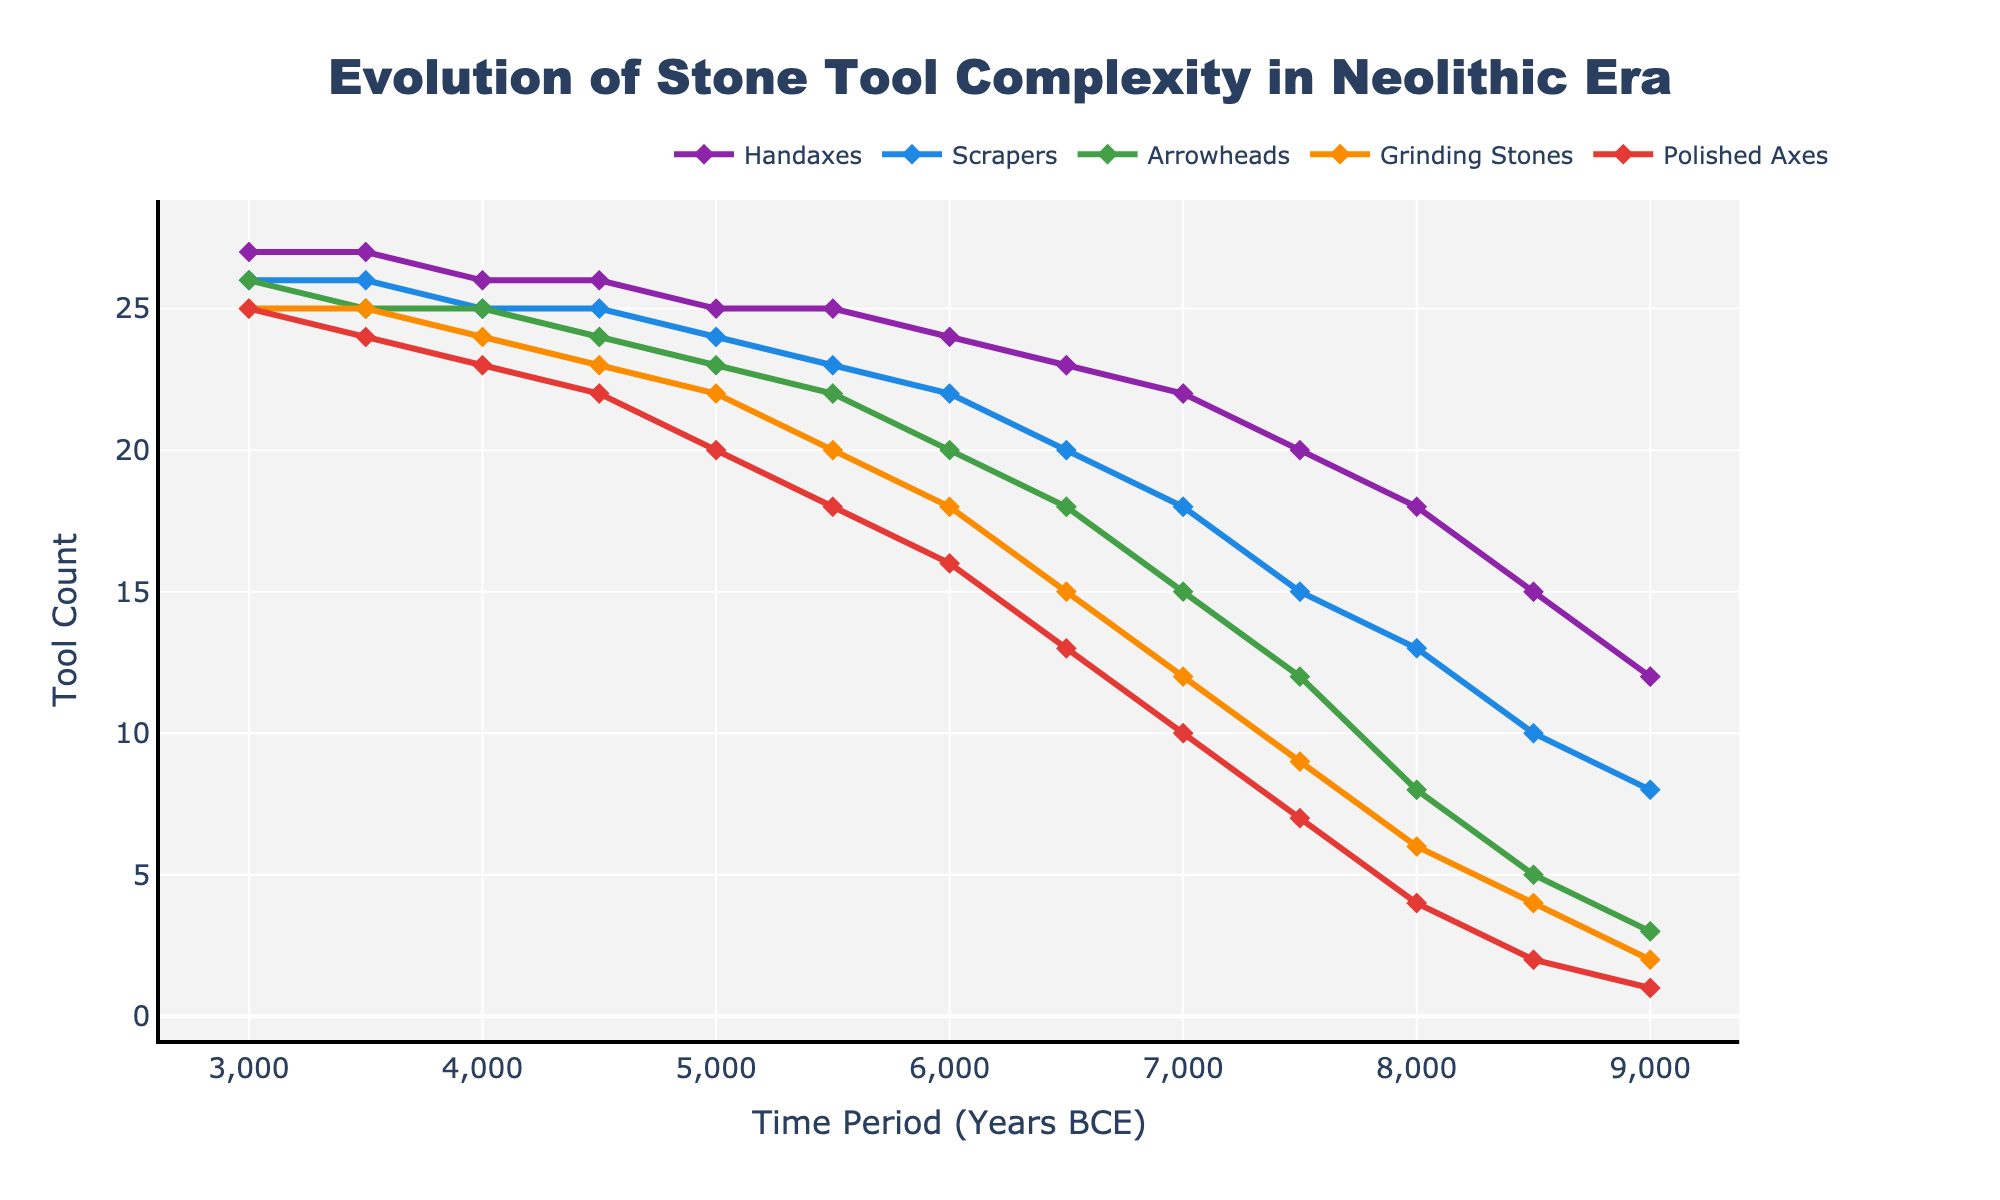What time period marks the first appearance of all five tool types in the chart? Identify the point where all lines start, indicating the presence of each tool type in the record. The first time period where all tools are present is 8500 BCE.
Answer: 8500 BCE Which tool type shows the highest increase in count from 9000 BCE to 8000 BCE? Compare the increases of each tool type between these periods by subtracting counts. Handaxes: 18-12=6, Scrapers: 13-8=5, Arrowheads: 8-3=5, Grinding Stones: 6-2=4, Polished Axes: 4-1=3. Handaxes show the highest increase of 6.
Answer: Handaxes At what time period do Polished Axes first reach the same count as Arrowheads? Locate the point in time where the values for both tools are identical. In 6000 BCE, both Polished Axes and Arrowheads reach a count of 16.
Answer: 6000 BCE How many more Grinding Stones were there compared to Arrowheads in 5500 BCE? Subtract the count of Arrowheads from the count of Grinding Stones in 5500 BCE. Grinding Stones: 20, Arrowheads: 22. The difference is 20-22=-2.
Answer: -2 (2 fewer Grinding Stones) Which time period shows the smallest increase in the number of handaxes compared to the previous period? Calculate the differences between consecutive periods for Handaxes, then identify the smallest increase. Between 8500-9000: 3, 8000-8500: 3, 7500-8000: 2, 7000-7500: 2, 6500-7000: 1, 6000-6500: 1, 5500-6000: 1, 5000-5500: 0, 4500-5000: 1, 4000-4500: 0, 3500-4000: 1, 3000-3500: 0. The smallest increase is 0, occurring from 5500 BCE onward.
Answer: 3000 BCE, 4000 BCE, 5000 BCE, 5500 BCE What is the median count of Scrapers over the entire time period? Arrange the scraper counts in ascending order and find the middle value(s). Sorted counts: 8, 10, 13, 15, 18, 20, 22, 23, 24, 25, 25, 26, 26. With an odd number of data points (n=13), the median is the middle value, which is 22.
Answer: 22 